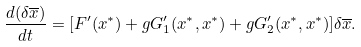Convert formula to latex. <formula><loc_0><loc_0><loc_500><loc_500>\frac { d ( \delta { \overline { x } } ) } { d t } = { \left [ { { F } ^ { \prime } ( { x } ^ { \ast } ) + g { G } ^ { \prime } _ { 1 } ( { x } ^ { \ast } , { x } ^ { \ast } ) + g { G } ^ { \prime } _ { 2 } ( { x } ^ { \ast } , { x } ^ { \ast } ) } \right ] } \delta \overline { x } .</formula> 